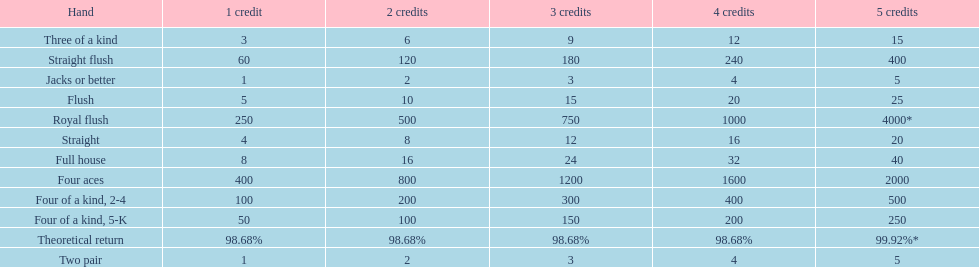After winning on four credits with a full house, what is your payout? 32. 